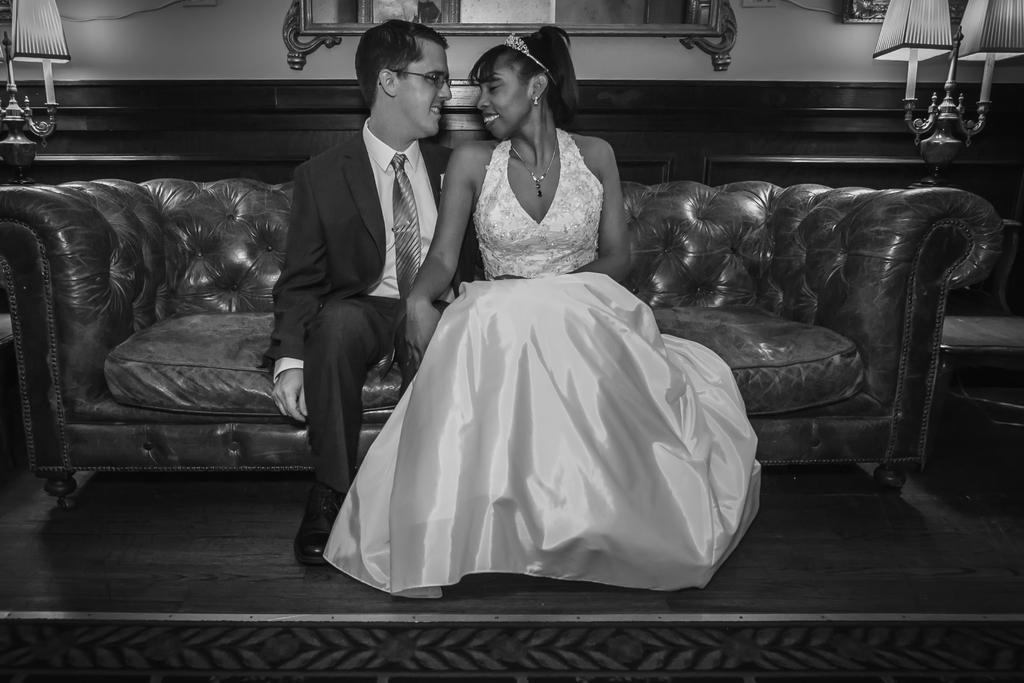Please provide a concise description of this image. In this image I can see there are two people sitting on the couch and a man wearing shoes and glass. 